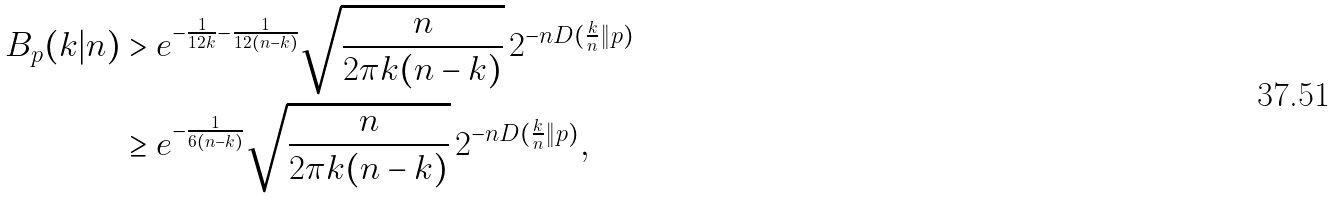Convert formula to latex. <formula><loc_0><loc_0><loc_500><loc_500>B _ { p } ( k | n ) & > e ^ { - \frac { 1 } { 1 2 k } - \frac { 1 } { 1 2 ( n - k ) } } \sqrt { \frac { n } { 2 \pi k ( n - k ) } } \, 2 ^ { - n D ( \frac { k } { n } \| p ) } \\ & \geq e ^ { - \frac { 1 } { 6 ( n - k ) } } \sqrt { \frac { n } { 2 \pi k ( n - k ) } } \, 2 ^ { - n D ( \frac { k } { n } \| p ) } ,</formula> 